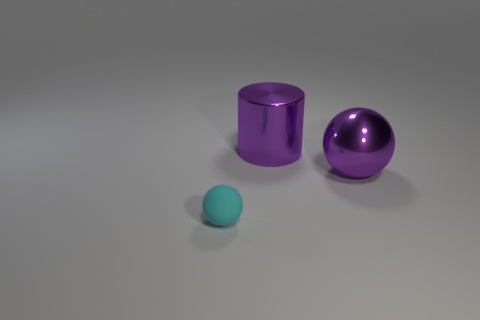Subtract 2 spheres. How many spheres are left? 0 Add 1 gray blocks. How many objects exist? 4 Subtract all cyan balls. How many balls are left? 1 Subtract all spheres. How many objects are left? 1 Add 3 big purple objects. How many big purple objects are left? 5 Add 3 big purple metallic spheres. How many big purple metallic spheres exist? 4 Subtract 0 brown balls. How many objects are left? 3 Subtract all green cylinders. Subtract all red balls. How many cylinders are left? 1 Subtract all green cubes. How many gray cylinders are left? 0 Subtract all red shiny balls. Subtract all large shiny objects. How many objects are left? 1 